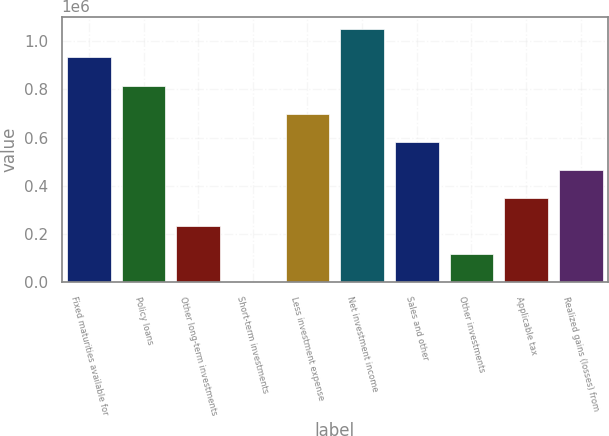<chart> <loc_0><loc_0><loc_500><loc_500><bar_chart><fcel>Fixed maturities available for<fcel>Policy loans<fcel>Other long-term investments<fcel>Short-term investments<fcel>Less investment expense<fcel>Net investment income<fcel>Sales and other<fcel>Other investments<fcel>Applicable tax<fcel>Realized gains (losses) from<nl><fcel>932845<fcel>816251<fcel>233282<fcel>95<fcel>699657<fcel>1.04944e+06<fcel>583064<fcel>116689<fcel>349876<fcel>466470<nl></chart> 